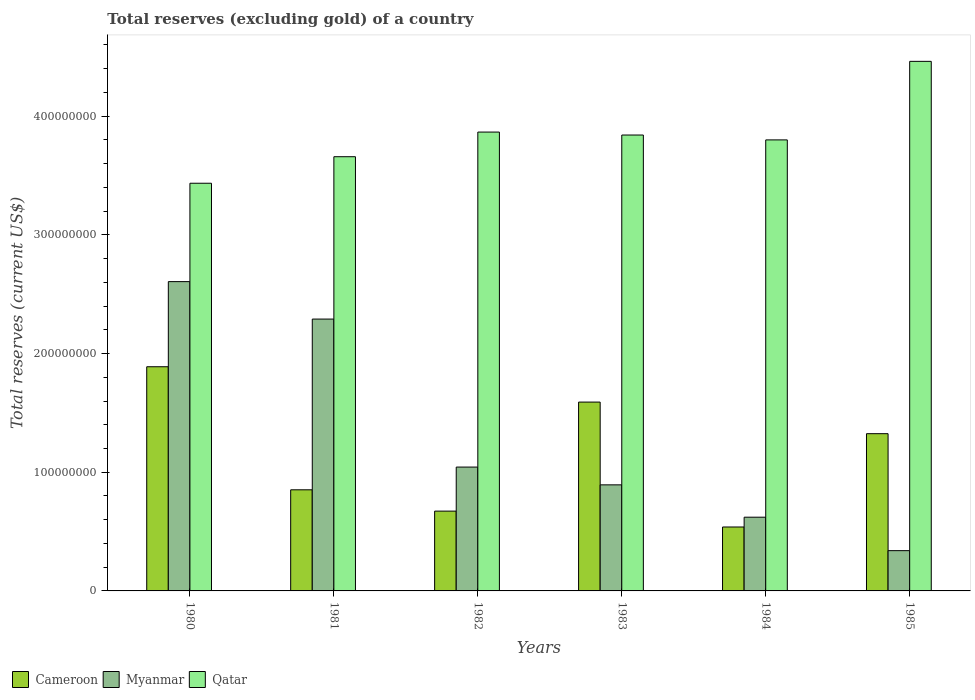How many groups of bars are there?
Make the answer very short. 6. How many bars are there on the 2nd tick from the right?
Ensure brevity in your answer.  3. What is the total reserves (excluding gold) in Myanmar in 1985?
Keep it short and to the point. 3.39e+07. Across all years, what is the maximum total reserves (excluding gold) in Cameroon?
Your response must be concise. 1.89e+08. Across all years, what is the minimum total reserves (excluding gold) in Cameroon?
Give a very brief answer. 5.39e+07. In which year was the total reserves (excluding gold) in Myanmar maximum?
Provide a short and direct response. 1980. In which year was the total reserves (excluding gold) in Qatar minimum?
Your answer should be compact. 1980. What is the total total reserves (excluding gold) in Myanmar in the graph?
Provide a short and direct response. 7.79e+08. What is the difference between the total reserves (excluding gold) in Myanmar in 1980 and that in 1982?
Keep it short and to the point. 1.56e+08. What is the difference between the total reserves (excluding gold) in Myanmar in 1982 and the total reserves (excluding gold) in Qatar in 1983?
Make the answer very short. -2.80e+08. What is the average total reserves (excluding gold) in Myanmar per year?
Keep it short and to the point. 1.30e+08. In the year 1982, what is the difference between the total reserves (excluding gold) in Myanmar and total reserves (excluding gold) in Cameroon?
Make the answer very short. 3.71e+07. What is the ratio of the total reserves (excluding gold) in Qatar in 1980 to that in 1982?
Provide a succinct answer. 0.89. What is the difference between the highest and the second highest total reserves (excluding gold) in Myanmar?
Your response must be concise. 3.16e+07. What is the difference between the highest and the lowest total reserves (excluding gold) in Qatar?
Provide a succinct answer. 1.03e+08. Is the sum of the total reserves (excluding gold) in Qatar in 1981 and 1982 greater than the maximum total reserves (excluding gold) in Myanmar across all years?
Keep it short and to the point. Yes. What does the 3rd bar from the left in 1980 represents?
Keep it short and to the point. Qatar. What does the 3rd bar from the right in 1981 represents?
Keep it short and to the point. Cameroon. Is it the case that in every year, the sum of the total reserves (excluding gold) in Qatar and total reserves (excluding gold) in Myanmar is greater than the total reserves (excluding gold) in Cameroon?
Your answer should be very brief. Yes. How many bars are there?
Offer a terse response. 18. Are all the bars in the graph horizontal?
Keep it short and to the point. No. How many years are there in the graph?
Give a very brief answer. 6. What is the difference between two consecutive major ticks on the Y-axis?
Your answer should be very brief. 1.00e+08. Are the values on the major ticks of Y-axis written in scientific E-notation?
Make the answer very short. No. Does the graph contain any zero values?
Give a very brief answer. No. Where does the legend appear in the graph?
Provide a short and direct response. Bottom left. How many legend labels are there?
Your answer should be compact. 3. What is the title of the graph?
Offer a very short reply. Total reserves (excluding gold) of a country. What is the label or title of the X-axis?
Give a very brief answer. Years. What is the label or title of the Y-axis?
Make the answer very short. Total reserves (current US$). What is the Total reserves (current US$) of Cameroon in 1980?
Offer a terse response. 1.89e+08. What is the Total reserves (current US$) in Myanmar in 1980?
Provide a short and direct response. 2.61e+08. What is the Total reserves (current US$) of Qatar in 1980?
Make the answer very short. 3.43e+08. What is the Total reserves (current US$) of Cameroon in 1981?
Your answer should be compact. 8.52e+07. What is the Total reserves (current US$) of Myanmar in 1981?
Your answer should be compact. 2.29e+08. What is the Total reserves (current US$) in Qatar in 1981?
Provide a succinct answer. 3.66e+08. What is the Total reserves (current US$) in Cameroon in 1982?
Provide a short and direct response. 6.72e+07. What is the Total reserves (current US$) of Myanmar in 1982?
Make the answer very short. 1.04e+08. What is the Total reserves (current US$) of Qatar in 1982?
Provide a short and direct response. 3.87e+08. What is the Total reserves (current US$) of Cameroon in 1983?
Ensure brevity in your answer.  1.59e+08. What is the Total reserves (current US$) of Myanmar in 1983?
Offer a very short reply. 8.94e+07. What is the Total reserves (current US$) in Qatar in 1983?
Make the answer very short. 3.84e+08. What is the Total reserves (current US$) in Cameroon in 1984?
Ensure brevity in your answer.  5.39e+07. What is the Total reserves (current US$) of Myanmar in 1984?
Provide a short and direct response. 6.21e+07. What is the Total reserves (current US$) in Qatar in 1984?
Offer a terse response. 3.80e+08. What is the Total reserves (current US$) of Cameroon in 1985?
Give a very brief answer. 1.32e+08. What is the Total reserves (current US$) of Myanmar in 1985?
Your answer should be compact. 3.39e+07. What is the Total reserves (current US$) of Qatar in 1985?
Your answer should be compact. 4.46e+08. Across all years, what is the maximum Total reserves (current US$) of Cameroon?
Your answer should be very brief. 1.89e+08. Across all years, what is the maximum Total reserves (current US$) of Myanmar?
Keep it short and to the point. 2.61e+08. Across all years, what is the maximum Total reserves (current US$) in Qatar?
Offer a terse response. 4.46e+08. Across all years, what is the minimum Total reserves (current US$) in Cameroon?
Give a very brief answer. 5.39e+07. Across all years, what is the minimum Total reserves (current US$) in Myanmar?
Offer a terse response. 3.39e+07. Across all years, what is the minimum Total reserves (current US$) in Qatar?
Offer a terse response. 3.43e+08. What is the total Total reserves (current US$) of Cameroon in the graph?
Keep it short and to the point. 6.87e+08. What is the total Total reserves (current US$) in Myanmar in the graph?
Make the answer very short. 7.79e+08. What is the total Total reserves (current US$) of Qatar in the graph?
Keep it short and to the point. 2.31e+09. What is the difference between the Total reserves (current US$) in Cameroon in 1980 and that in 1981?
Ensure brevity in your answer.  1.04e+08. What is the difference between the Total reserves (current US$) in Myanmar in 1980 and that in 1981?
Your answer should be compact. 3.16e+07. What is the difference between the Total reserves (current US$) in Qatar in 1980 and that in 1981?
Offer a very short reply. -2.24e+07. What is the difference between the Total reserves (current US$) of Cameroon in 1980 and that in 1982?
Offer a very short reply. 1.22e+08. What is the difference between the Total reserves (current US$) of Myanmar in 1980 and that in 1982?
Provide a succinct answer. 1.56e+08. What is the difference between the Total reserves (current US$) in Qatar in 1980 and that in 1982?
Make the answer very short. -4.31e+07. What is the difference between the Total reserves (current US$) in Cameroon in 1980 and that in 1983?
Your response must be concise. 2.98e+07. What is the difference between the Total reserves (current US$) of Myanmar in 1980 and that in 1983?
Offer a very short reply. 1.71e+08. What is the difference between the Total reserves (current US$) in Qatar in 1980 and that in 1983?
Your response must be concise. -4.06e+07. What is the difference between the Total reserves (current US$) of Cameroon in 1980 and that in 1984?
Make the answer very short. 1.35e+08. What is the difference between the Total reserves (current US$) of Myanmar in 1980 and that in 1984?
Ensure brevity in your answer.  1.98e+08. What is the difference between the Total reserves (current US$) of Qatar in 1980 and that in 1984?
Ensure brevity in your answer.  -3.65e+07. What is the difference between the Total reserves (current US$) of Cameroon in 1980 and that in 1985?
Give a very brief answer. 5.64e+07. What is the difference between the Total reserves (current US$) of Myanmar in 1980 and that in 1985?
Ensure brevity in your answer.  2.27e+08. What is the difference between the Total reserves (current US$) of Qatar in 1980 and that in 1985?
Give a very brief answer. -1.03e+08. What is the difference between the Total reserves (current US$) in Cameroon in 1981 and that in 1982?
Offer a very short reply. 1.80e+07. What is the difference between the Total reserves (current US$) in Myanmar in 1981 and that in 1982?
Offer a terse response. 1.25e+08. What is the difference between the Total reserves (current US$) of Qatar in 1981 and that in 1982?
Your answer should be very brief. -2.08e+07. What is the difference between the Total reserves (current US$) of Cameroon in 1981 and that in 1983?
Offer a terse response. -7.39e+07. What is the difference between the Total reserves (current US$) in Myanmar in 1981 and that in 1983?
Offer a terse response. 1.40e+08. What is the difference between the Total reserves (current US$) of Qatar in 1981 and that in 1983?
Make the answer very short. -1.83e+07. What is the difference between the Total reserves (current US$) in Cameroon in 1981 and that in 1984?
Offer a very short reply. 3.13e+07. What is the difference between the Total reserves (current US$) in Myanmar in 1981 and that in 1984?
Offer a very short reply. 1.67e+08. What is the difference between the Total reserves (current US$) in Qatar in 1981 and that in 1984?
Your response must be concise. -1.42e+07. What is the difference between the Total reserves (current US$) in Cameroon in 1981 and that in 1985?
Ensure brevity in your answer.  -4.73e+07. What is the difference between the Total reserves (current US$) of Myanmar in 1981 and that in 1985?
Provide a succinct answer. 1.95e+08. What is the difference between the Total reserves (current US$) in Qatar in 1981 and that in 1985?
Your answer should be compact. -8.03e+07. What is the difference between the Total reserves (current US$) of Cameroon in 1982 and that in 1983?
Offer a very short reply. -9.19e+07. What is the difference between the Total reserves (current US$) in Myanmar in 1982 and that in 1983?
Your answer should be very brief. 1.50e+07. What is the difference between the Total reserves (current US$) in Qatar in 1982 and that in 1983?
Make the answer very short. 2.48e+06. What is the difference between the Total reserves (current US$) in Cameroon in 1982 and that in 1984?
Your answer should be compact. 1.34e+07. What is the difference between the Total reserves (current US$) of Myanmar in 1982 and that in 1984?
Offer a terse response. 4.22e+07. What is the difference between the Total reserves (current US$) of Qatar in 1982 and that in 1984?
Provide a short and direct response. 6.59e+06. What is the difference between the Total reserves (current US$) in Cameroon in 1982 and that in 1985?
Give a very brief answer. -6.52e+07. What is the difference between the Total reserves (current US$) of Myanmar in 1982 and that in 1985?
Keep it short and to the point. 7.04e+07. What is the difference between the Total reserves (current US$) in Qatar in 1982 and that in 1985?
Provide a succinct answer. -5.96e+07. What is the difference between the Total reserves (current US$) in Cameroon in 1983 and that in 1984?
Give a very brief answer. 1.05e+08. What is the difference between the Total reserves (current US$) in Myanmar in 1983 and that in 1984?
Offer a very short reply. 2.72e+07. What is the difference between the Total reserves (current US$) of Qatar in 1983 and that in 1984?
Your response must be concise. 4.10e+06. What is the difference between the Total reserves (current US$) in Cameroon in 1983 and that in 1985?
Offer a terse response. 2.66e+07. What is the difference between the Total reserves (current US$) of Myanmar in 1983 and that in 1985?
Provide a succinct answer. 5.54e+07. What is the difference between the Total reserves (current US$) of Qatar in 1983 and that in 1985?
Offer a terse response. -6.21e+07. What is the difference between the Total reserves (current US$) in Cameroon in 1984 and that in 1985?
Your answer should be very brief. -7.86e+07. What is the difference between the Total reserves (current US$) of Myanmar in 1984 and that in 1985?
Your response must be concise. 2.82e+07. What is the difference between the Total reserves (current US$) of Qatar in 1984 and that in 1985?
Keep it short and to the point. -6.62e+07. What is the difference between the Total reserves (current US$) in Cameroon in 1980 and the Total reserves (current US$) in Myanmar in 1981?
Make the answer very short. -4.02e+07. What is the difference between the Total reserves (current US$) in Cameroon in 1980 and the Total reserves (current US$) in Qatar in 1981?
Give a very brief answer. -1.77e+08. What is the difference between the Total reserves (current US$) in Myanmar in 1980 and the Total reserves (current US$) in Qatar in 1981?
Your answer should be compact. -1.05e+08. What is the difference between the Total reserves (current US$) in Cameroon in 1980 and the Total reserves (current US$) in Myanmar in 1982?
Your answer should be compact. 8.45e+07. What is the difference between the Total reserves (current US$) in Cameroon in 1980 and the Total reserves (current US$) in Qatar in 1982?
Your answer should be very brief. -1.98e+08. What is the difference between the Total reserves (current US$) in Myanmar in 1980 and the Total reserves (current US$) in Qatar in 1982?
Offer a very short reply. -1.26e+08. What is the difference between the Total reserves (current US$) in Cameroon in 1980 and the Total reserves (current US$) in Myanmar in 1983?
Offer a very short reply. 9.95e+07. What is the difference between the Total reserves (current US$) in Cameroon in 1980 and the Total reserves (current US$) in Qatar in 1983?
Offer a very short reply. -1.95e+08. What is the difference between the Total reserves (current US$) of Myanmar in 1980 and the Total reserves (current US$) of Qatar in 1983?
Your answer should be compact. -1.24e+08. What is the difference between the Total reserves (current US$) of Cameroon in 1980 and the Total reserves (current US$) of Myanmar in 1984?
Your response must be concise. 1.27e+08. What is the difference between the Total reserves (current US$) in Cameroon in 1980 and the Total reserves (current US$) in Qatar in 1984?
Give a very brief answer. -1.91e+08. What is the difference between the Total reserves (current US$) in Myanmar in 1980 and the Total reserves (current US$) in Qatar in 1984?
Make the answer very short. -1.19e+08. What is the difference between the Total reserves (current US$) in Cameroon in 1980 and the Total reserves (current US$) in Myanmar in 1985?
Keep it short and to the point. 1.55e+08. What is the difference between the Total reserves (current US$) in Cameroon in 1980 and the Total reserves (current US$) in Qatar in 1985?
Your response must be concise. -2.57e+08. What is the difference between the Total reserves (current US$) in Myanmar in 1980 and the Total reserves (current US$) in Qatar in 1985?
Your response must be concise. -1.86e+08. What is the difference between the Total reserves (current US$) in Cameroon in 1981 and the Total reserves (current US$) in Myanmar in 1982?
Your answer should be very brief. -1.92e+07. What is the difference between the Total reserves (current US$) of Cameroon in 1981 and the Total reserves (current US$) of Qatar in 1982?
Ensure brevity in your answer.  -3.01e+08. What is the difference between the Total reserves (current US$) in Myanmar in 1981 and the Total reserves (current US$) in Qatar in 1982?
Offer a very short reply. -1.58e+08. What is the difference between the Total reserves (current US$) in Cameroon in 1981 and the Total reserves (current US$) in Myanmar in 1983?
Provide a short and direct response. -4.17e+06. What is the difference between the Total reserves (current US$) in Cameroon in 1981 and the Total reserves (current US$) in Qatar in 1983?
Offer a terse response. -2.99e+08. What is the difference between the Total reserves (current US$) in Myanmar in 1981 and the Total reserves (current US$) in Qatar in 1983?
Offer a terse response. -1.55e+08. What is the difference between the Total reserves (current US$) of Cameroon in 1981 and the Total reserves (current US$) of Myanmar in 1984?
Your response must be concise. 2.31e+07. What is the difference between the Total reserves (current US$) in Cameroon in 1981 and the Total reserves (current US$) in Qatar in 1984?
Offer a very short reply. -2.95e+08. What is the difference between the Total reserves (current US$) in Myanmar in 1981 and the Total reserves (current US$) in Qatar in 1984?
Ensure brevity in your answer.  -1.51e+08. What is the difference between the Total reserves (current US$) of Cameroon in 1981 and the Total reserves (current US$) of Myanmar in 1985?
Keep it short and to the point. 5.13e+07. What is the difference between the Total reserves (current US$) in Cameroon in 1981 and the Total reserves (current US$) in Qatar in 1985?
Ensure brevity in your answer.  -3.61e+08. What is the difference between the Total reserves (current US$) of Myanmar in 1981 and the Total reserves (current US$) of Qatar in 1985?
Make the answer very short. -2.17e+08. What is the difference between the Total reserves (current US$) in Cameroon in 1982 and the Total reserves (current US$) in Myanmar in 1983?
Give a very brief answer. -2.21e+07. What is the difference between the Total reserves (current US$) in Cameroon in 1982 and the Total reserves (current US$) in Qatar in 1983?
Ensure brevity in your answer.  -3.17e+08. What is the difference between the Total reserves (current US$) in Myanmar in 1982 and the Total reserves (current US$) in Qatar in 1983?
Offer a very short reply. -2.80e+08. What is the difference between the Total reserves (current US$) in Cameroon in 1982 and the Total reserves (current US$) in Myanmar in 1984?
Make the answer very short. 5.11e+06. What is the difference between the Total reserves (current US$) in Cameroon in 1982 and the Total reserves (current US$) in Qatar in 1984?
Your answer should be very brief. -3.13e+08. What is the difference between the Total reserves (current US$) in Myanmar in 1982 and the Total reserves (current US$) in Qatar in 1984?
Offer a terse response. -2.76e+08. What is the difference between the Total reserves (current US$) of Cameroon in 1982 and the Total reserves (current US$) of Myanmar in 1985?
Offer a very short reply. 3.33e+07. What is the difference between the Total reserves (current US$) in Cameroon in 1982 and the Total reserves (current US$) in Qatar in 1985?
Offer a very short reply. -3.79e+08. What is the difference between the Total reserves (current US$) in Myanmar in 1982 and the Total reserves (current US$) in Qatar in 1985?
Keep it short and to the point. -3.42e+08. What is the difference between the Total reserves (current US$) of Cameroon in 1983 and the Total reserves (current US$) of Myanmar in 1984?
Offer a terse response. 9.70e+07. What is the difference between the Total reserves (current US$) of Cameroon in 1983 and the Total reserves (current US$) of Qatar in 1984?
Your response must be concise. -2.21e+08. What is the difference between the Total reserves (current US$) of Myanmar in 1983 and the Total reserves (current US$) of Qatar in 1984?
Keep it short and to the point. -2.91e+08. What is the difference between the Total reserves (current US$) in Cameroon in 1983 and the Total reserves (current US$) in Myanmar in 1985?
Your answer should be very brief. 1.25e+08. What is the difference between the Total reserves (current US$) in Cameroon in 1983 and the Total reserves (current US$) in Qatar in 1985?
Provide a short and direct response. -2.87e+08. What is the difference between the Total reserves (current US$) in Myanmar in 1983 and the Total reserves (current US$) in Qatar in 1985?
Ensure brevity in your answer.  -3.57e+08. What is the difference between the Total reserves (current US$) in Cameroon in 1984 and the Total reserves (current US$) in Myanmar in 1985?
Offer a terse response. 1.99e+07. What is the difference between the Total reserves (current US$) in Cameroon in 1984 and the Total reserves (current US$) in Qatar in 1985?
Keep it short and to the point. -3.92e+08. What is the difference between the Total reserves (current US$) in Myanmar in 1984 and the Total reserves (current US$) in Qatar in 1985?
Your answer should be very brief. -3.84e+08. What is the average Total reserves (current US$) of Cameroon per year?
Your answer should be compact. 1.14e+08. What is the average Total reserves (current US$) in Myanmar per year?
Provide a succinct answer. 1.30e+08. What is the average Total reserves (current US$) in Qatar per year?
Offer a very short reply. 3.84e+08. In the year 1980, what is the difference between the Total reserves (current US$) of Cameroon and Total reserves (current US$) of Myanmar?
Give a very brief answer. -7.17e+07. In the year 1980, what is the difference between the Total reserves (current US$) in Cameroon and Total reserves (current US$) in Qatar?
Ensure brevity in your answer.  -1.55e+08. In the year 1980, what is the difference between the Total reserves (current US$) in Myanmar and Total reserves (current US$) in Qatar?
Provide a succinct answer. -8.29e+07. In the year 1981, what is the difference between the Total reserves (current US$) in Cameroon and Total reserves (current US$) in Myanmar?
Your response must be concise. -1.44e+08. In the year 1981, what is the difference between the Total reserves (current US$) of Cameroon and Total reserves (current US$) of Qatar?
Your answer should be very brief. -2.81e+08. In the year 1981, what is the difference between the Total reserves (current US$) in Myanmar and Total reserves (current US$) in Qatar?
Your answer should be very brief. -1.37e+08. In the year 1982, what is the difference between the Total reserves (current US$) of Cameroon and Total reserves (current US$) of Myanmar?
Your answer should be very brief. -3.71e+07. In the year 1982, what is the difference between the Total reserves (current US$) in Cameroon and Total reserves (current US$) in Qatar?
Your response must be concise. -3.19e+08. In the year 1982, what is the difference between the Total reserves (current US$) in Myanmar and Total reserves (current US$) in Qatar?
Give a very brief answer. -2.82e+08. In the year 1983, what is the difference between the Total reserves (current US$) in Cameroon and Total reserves (current US$) in Myanmar?
Your response must be concise. 6.97e+07. In the year 1983, what is the difference between the Total reserves (current US$) in Cameroon and Total reserves (current US$) in Qatar?
Your response must be concise. -2.25e+08. In the year 1983, what is the difference between the Total reserves (current US$) in Myanmar and Total reserves (current US$) in Qatar?
Provide a short and direct response. -2.95e+08. In the year 1984, what is the difference between the Total reserves (current US$) in Cameroon and Total reserves (current US$) in Myanmar?
Your answer should be very brief. -8.26e+06. In the year 1984, what is the difference between the Total reserves (current US$) of Cameroon and Total reserves (current US$) of Qatar?
Your answer should be very brief. -3.26e+08. In the year 1984, what is the difference between the Total reserves (current US$) of Myanmar and Total reserves (current US$) of Qatar?
Offer a very short reply. -3.18e+08. In the year 1985, what is the difference between the Total reserves (current US$) in Cameroon and Total reserves (current US$) in Myanmar?
Offer a very short reply. 9.85e+07. In the year 1985, what is the difference between the Total reserves (current US$) in Cameroon and Total reserves (current US$) in Qatar?
Give a very brief answer. -3.14e+08. In the year 1985, what is the difference between the Total reserves (current US$) in Myanmar and Total reserves (current US$) in Qatar?
Your answer should be compact. -4.12e+08. What is the ratio of the Total reserves (current US$) in Cameroon in 1980 to that in 1981?
Your answer should be compact. 2.22. What is the ratio of the Total reserves (current US$) in Myanmar in 1980 to that in 1981?
Ensure brevity in your answer.  1.14. What is the ratio of the Total reserves (current US$) in Qatar in 1980 to that in 1981?
Your answer should be very brief. 0.94. What is the ratio of the Total reserves (current US$) in Cameroon in 1980 to that in 1982?
Your answer should be very brief. 2.81. What is the ratio of the Total reserves (current US$) in Myanmar in 1980 to that in 1982?
Keep it short and to the point. 2.5. What is the ratio of the Total reserves (current US$) in Qatar in 1980 to that in 1982?
Offer a terse response. 0.89. What is the ratio of the Total reserves (current US$) in Cameroon in 1980 to that in 1983?
Offer a terse response. 1.19. What is the ratio of the Total reserves (current US$) in Myanmar in 1980 to that in 1983?
Your response must be concise. 2.92. What is the ratio of the Total reserves (current US$) of Qatar in 1980 to that in 1983?
Offer a very short reply. 0.89. What is the ratio of the Total reserves (current US$) of Cameroon in 1980 to that in 1984?
Provide a succinct answer. 3.51. What is the ratio of the Total reserves (current US$) of Myanmar in 1980 to that in 1984?
Provide a short and direct response. 4.2. What is the ratio of the Total reserves (current US$) in Qatar in 1980 to that in 1984?
Provide a short and direct response. 0.9. What is the ratio of the Total reserves (current US$) of Cameroon in 1980 to that in 1985?
Give a very brief answer. 1.43. What is the ratio of the Total reserves (current US$) of Myanmar in 1980 to that in 1985?
Ensure brevity in your answer.  7.68. What is the ratio of the Total reserves (current US$) of Qatar in 1980 to that in 1985?
Offer a very short reply. 0.77. What is the ratio of the Total reserves (current US$) in Cameroon in 1981 to that in 1982?
Offer a very short reply. 1.27. What is the ratio of the Total reserves (current US$) of Myanmar in 1981 to that in 1982?
Offer a terse response. 2.19. What is the ratio of the Total reserves (current US$) of Qatar in 1981 to that in 1982?
Provide a short and direct response. 0.95. What is the ratio of the Total reserves (current US$) of Cameroon in 1981 to that in 1983?
Offer a very short reply. 0.54. What is the ratio of the Total reserves (current US$) in Myanmar in 1981 to that in 1983?
Your answer should be very brief. 2.56. What is the ratio of the Total reserves (current US$) in Cameroon in 1981 to that in 1984?
Ensure brevity in your answer.  1.58. What is the ratio of the Total reserves (current US$) in Myanmar in 1981 to that in 1984?
Your answer should be very brief. 3.69. What is the ratio of the Total reserves (current US$) in Qatar in 1981 to that in 1984?
Your answer should be very brief. 0.96. What is the ratio of the Total reserves (current US$) in Cameroon in 1981 to that in 1985?
Your answer should be very brief. 0.64. What is the ratio of the Total reserves (current US$) of Myanmar in 1981 to that in 1985?
Provide a short and direct response. 6.75. What is the ratio of the Total reserves (current US$) of Qatar in 1981 to that in 1985?
Ensure brevity in your answer.  0.82. What is the ratio of the Total reserves (current US$) of Cameroon in 1982 to that in 1983?
Keep it short and to the point. 0.42. What is the ratio of the Total reserves (current US$) of Myanmar in 1982 to that in 1983?
Your answer should be very brief. 1.17. What is the ratio of the Total reserves (current US$) in Qatar in 1982 to that in 1983?
Provide a succinct answer. 1.01. What is the ratio of the Total reserves (current US$) in Cameroon in 1982 to that in 1984?
Give a very brief answer. 1.25. What is the ratio of the Total reserves (current US$) in Myanmar in 1982 to that in 1984?
Offer a terse response. 1.68. What is the ratio of the Total reserves (current US$) in Qatar in 1982 to that in 1984?
Give a very brief answer. 1.02. What is the ratio of the Total reserves (current US$) in Cameroon in 1982 to that in 1985?
Your response must be concise. 0.51. What is the ratio of the Total reserves (current US$) in Myanmar in 1982 to that in 1985?
Keep it short and to the point. 3.08. What is the ratio of the Total reserves (current US$) of Qatar in 1982 to that in 1985?
Ensure brevity in your answer.  0.87. What is the ratio of the Total reserves (current US$) in Cameroon in 1983 to that in 1984?
Ensure brevity in your answer.  2.95. What is the ratio of the Total reserves (current US$) of Myanmar in 1983 to that in 1984?
Your answer should be very brief. 1.44. What is the ratio of the Total reserves (current US$) of Qatar in 1983 to that in 1984?
Your answer should be very brief. 1.01. What is the ratio of the Total reserves (current US$) in Cameroon in 1983 to that in 1985?
Your answer should be compact. 1.2. What is the ratio of the Total reserves (current US$) of Myanmar in 1983 to that in 1985?
Keep it short and to the point. 2.63. What is the ratio of the Total reserves (current US$) of Qatar in 1983 to that in 1985?
Provide a short and direct response. 0.86. What is the ratio of the Total reserves (current US$) in Cameroon in 1984 to that in 1985?
Your response must be concise. 0.41. What is the ratio of the Total reserves (current US$) of Myanmar in 1984 to that in 1985?
Your response must be concise. 1.83. What is the ratio of the Total reserves (current US$) of Qatar in 1984 to that in 1985?
Your answer should be compact. 0.85. What is the difference between the highest and the second highest Total reserves (current US$) of Cameroon?
Offer a very short reply. 2.98e+07. What is the difference between the highest and the second highest Total reserves (current US$) of Myanmar?
Ensure brevity in your answer.  3.16e+07. What is the difference between the highest and the second highest Total reserves (current US$) in Qatar?
Give a very brief answer. 5.96e+07. What is the difference between the highest and the lowest Total reserves (current US$) of Cameroon?
Make the answer very short. 1.35e+08. What is the difference between the highest and the lowest Total reserves (current US$) in Myanmar?
Your response must be concise. 2.27e+08. What is the difference between the highest and the lowest Total reserves (current US$) in Qatar?
Your answer should be very brief. 1.03e+08. 